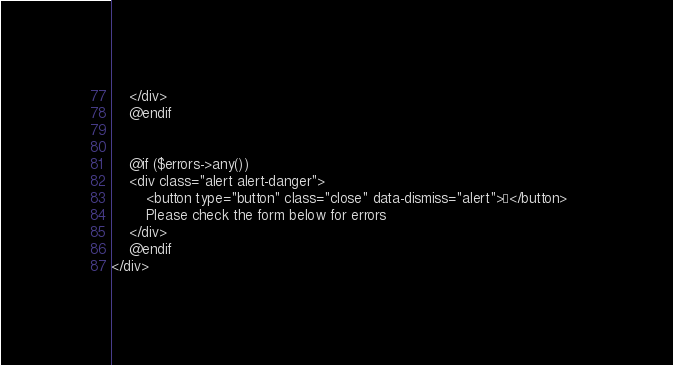<code> <loc_0><loc_0><loc_500><loc_500><_PHP_>    </div>
    @endif


    @if ($errors->any())
    <div class="alert alert-danger">
        <button type="button" class="close" data-dismiss="alert">×</button>	
        Please check the form below for errors
    </div>
    @endif
</div>
</code> 